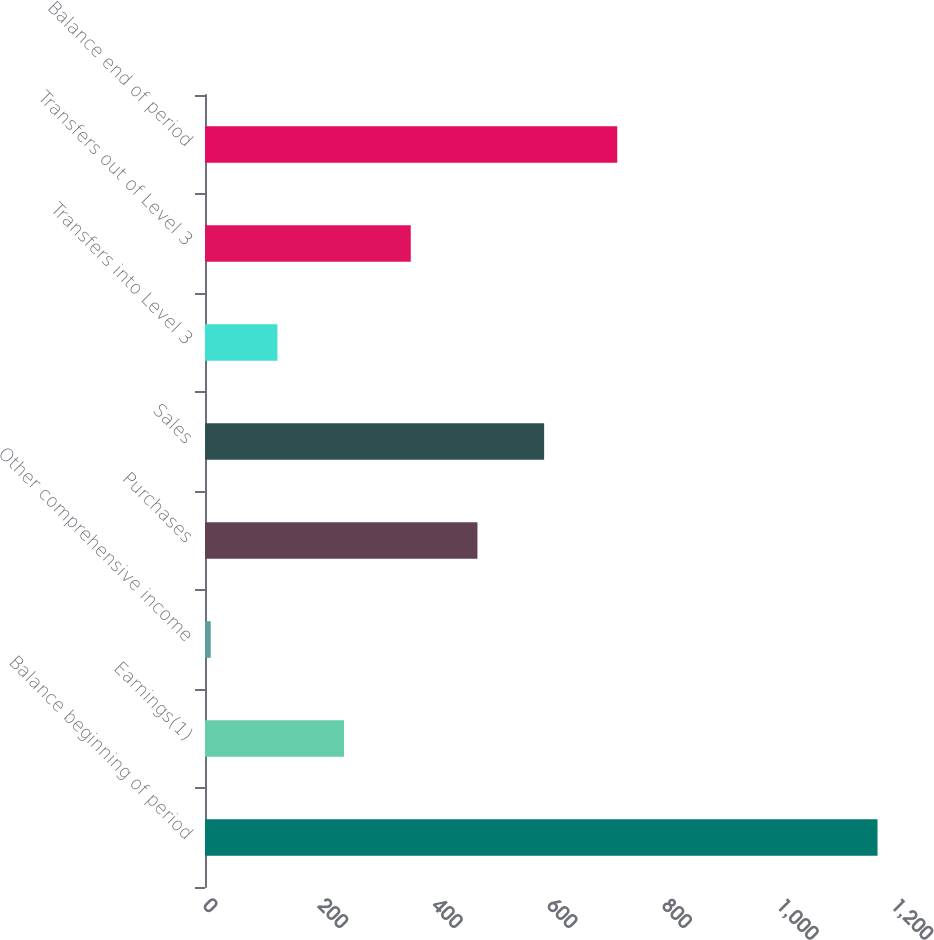<chart> <loc_0><loc_0><loc_500><loc_500><bar_chart><fcel>Balance beginning of period<fcel>Earnings(1)<fcel>Other comprehensive income<fcel>Purchases<fcel>Sales<fcel>Transfers into Level 3<fcel>Transfers out of Level 3<fcel>Balance end of period<nl><fcel>1173<fcel>242.6<fcel>10<fcel>475.2<fcel>591.5<fcel>126.3<fcel>358.9<fcel>719<nl></chart> 